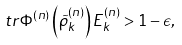<formula> <loc_0><loc_0><loc_500><loc_500>\ t r \Phi ^ { ( n ) } \left ( { \tilde { \rho } } ^ { ( n ) } _ { k } \right ) E ^ { ( n ) } _ { k } > 1 - \epsilon ,</formula> 